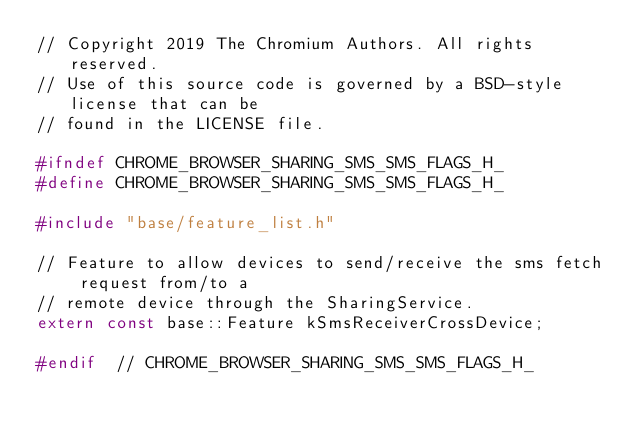<code> <loc_0><loc_0><loc_500><loc_500><_C_>// Copyright 2019 The Chromium Authors. All rights reserved.
// Use of this source code is governed by a BSD-style license that can be
// found in the LICENSE file.

#ifndef CHROME_BROWSER_SHARING_SMS_SMS_FLAGS_H_
#define CHROME_BROWSER_SHARING_SMS_SMS_FLAGS_H_

#include "base/feature_list.h"

// Feature to allow devices to send/receive the sms fetch request from/to a
// remote device through the SharingService.
extern const base::Feature kSmsReceiverCrossDevice;

#endif  // CHROME_BROWSER_SHARING_SMS_SMS_FLAGS_H_
</code> 